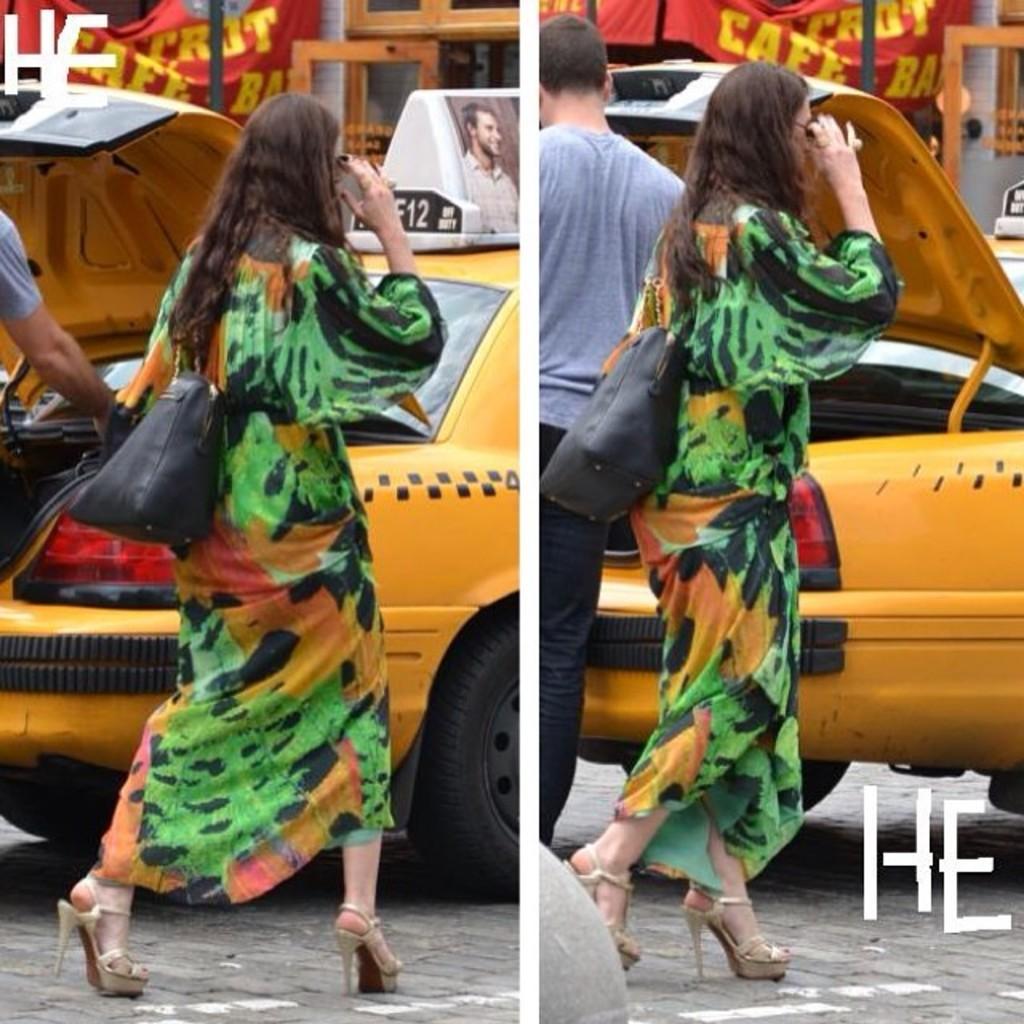What number is on the sign?
Your response must be concise. 12. What white letters are written on both images?
Provide a short and direct response. He. 